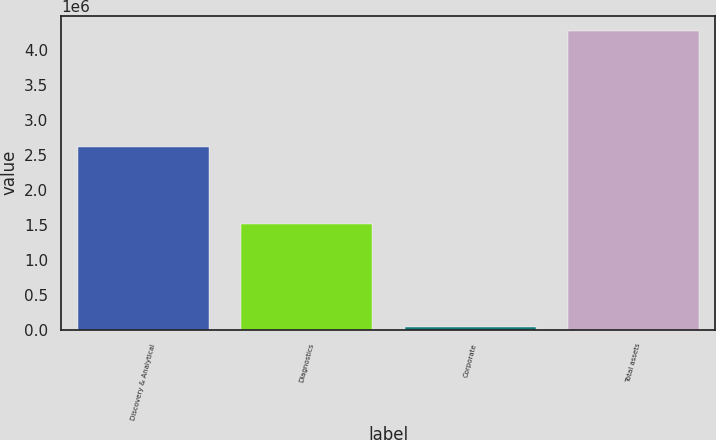Convert chart to OTSL. <chart><loc_0><loc_0><loc_500><loc_500><bar_chart><fcel>Discovery & Analytical<fcel>Diagnostics<fcel>Corporate<fcel>Total assets<nl><fcel>2.61276e+06<fcel>1.50538e+06<fcel>31171<fcel>4.27668e+06<nl></chart> 